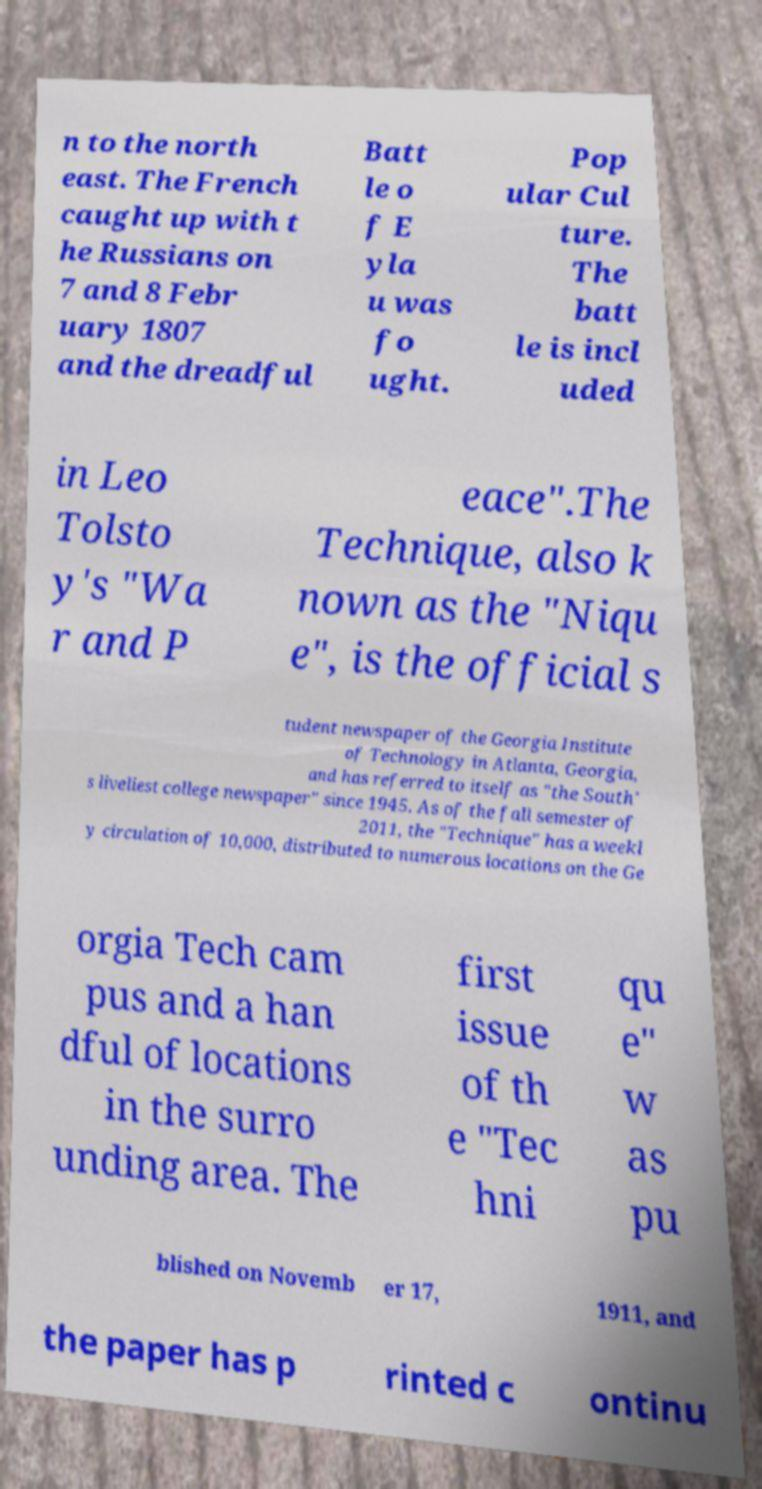Please identify and transcribe the text found in this image. n to the north east. The French caught up with t he Russians on 7 and 8 Febr uary 1807 and the dreadful Batt le o f E yla u was fo ught. Pop ular Cul ture. The batt le is incl uded in Leo Tolsto y's "Wa r and P eace".The Technique, also k nown as the "Niqu e", is the official s tudent newspaper of the Georgia Institute of Technology in Atlanta, Georgia, and has referred to itself as "the South' s liveliest college newspaper" since 1945. As of the fall semester of 2011, the "Technique" has a weekl y circulation of 10,000, distributed to numerous locations on the Ge orgia Tech cam pus and a han dful of locations in the surro unding area. The first issue of th e "Tec hni qu e" w as pu blished on Novemb er 17, 1911, and the paper has p rinted c ontinu 